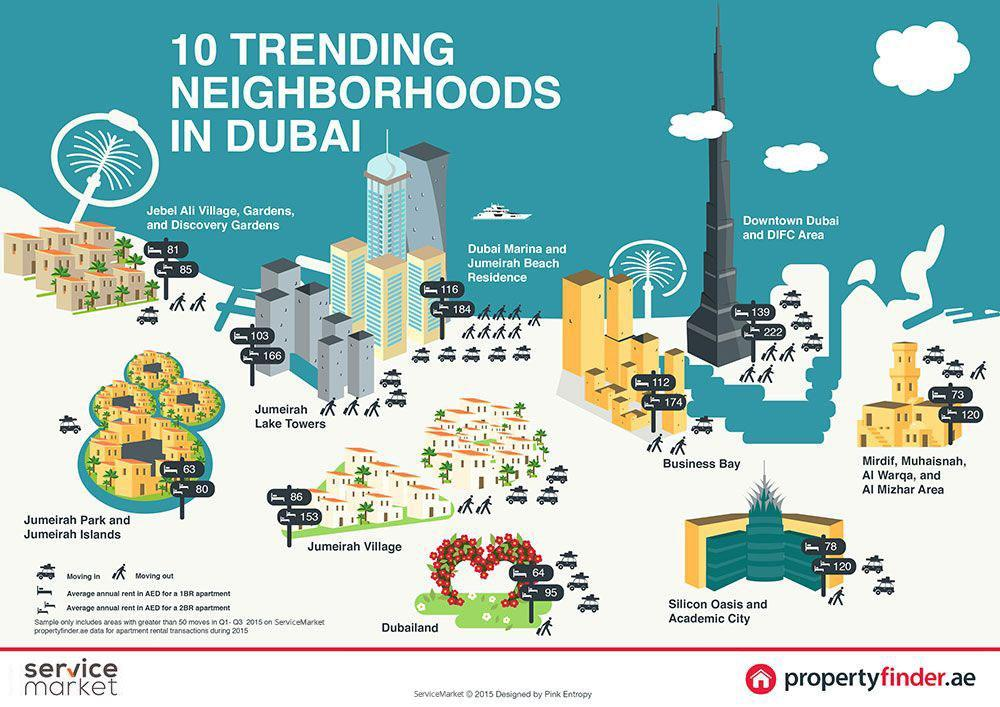How many neighborhoods shown in the graphic have average rent for a 2BR apartment below 100AED?
Answer the question with a short phrase. 3 In which neighborhood can we find a 1BR apartment at an average annual rent of 78 AED? Silicon Oasis and Academic City What is the lowest average rent for 2BR apartments shown in this infographic? 80 What is the average annual rent in AED for a 2BR apartment in Jebel Ali Village? 85 What is the highest average rent for 1BR apartments shown in this infographic? 139 How many neighborhoods shown in the graphic have average rent for a 1BR apartment above 100AED? 4 Which neighborhood shown in the graphic has the lowest annual rent rates? Jumeirah Park and Jumeirah Islands Which neighborhood shown in the graphic has the highest annual rent rates? Downtown Dubai and DIFC Area In which neighborhood can we find a 2BR apartment at an average annual rent of 174 AED? Business Bay What is the average annual rent in AED for a 1BR apartment in Jumeirah Lake Towers? 103 